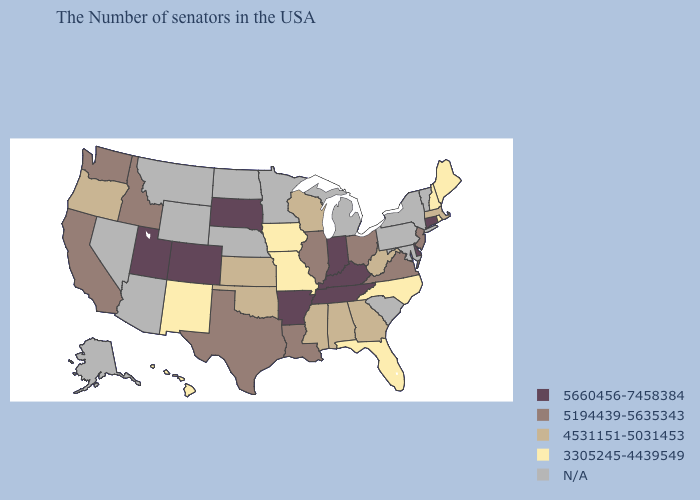What is the highest value in states that border Iowa?
Short answer required. 5660456-7458384. Which states have the highest value in the USA?
Quick response, please. Connecticut, Delaware, Kentucky, Indiana, Tennessee, Arkansas, South Dakota, Colorado, Utah. Name the states that have a value in the range 5194439-5635343?
Be succinct. New Jersey, Virginia, Ohio, Illinois, Louisiana, Texas, Idaho, California, Washington. What is the value of Maine?
Answer briefly. 3305245-4439549. Among the states that border Missouri , does Iowa have the lowest value?
Keep it brief. Yes. What is the value of Maine?
Give a very brief answer. 3305245-4439549. What is the lowest value in states that border Montana?
Answer briefly. 5194439-5635343. Among the states that border Michigan , which have the highest value?
Answer briefly. Indiana. What is the value of New Mexico?
Give a very brief answer. 3305245-4439549. Name the states that have a value in the range 3305245-4439549?
Keep it brief. Maine, Rhode Island, New Hampshire, North Carolina, Florida, Missouri, Iowa, New Mexico, Hawaii. What is the lowest value in the Northeast?
Give a very brief answer. 3305245-4439549. What is the value of Nebraska?
Keep it brief. N/A. Does South Dakota have the highest value in the MidWest?
Write a very short answer. Yes. Name the states that have a value in the range 5660456-7458384?
Short answer required. Connecticut, Delaware, Kentucky, Indiana, Tennessee, Arkansas, South Dakota, Colorado, Utah. 